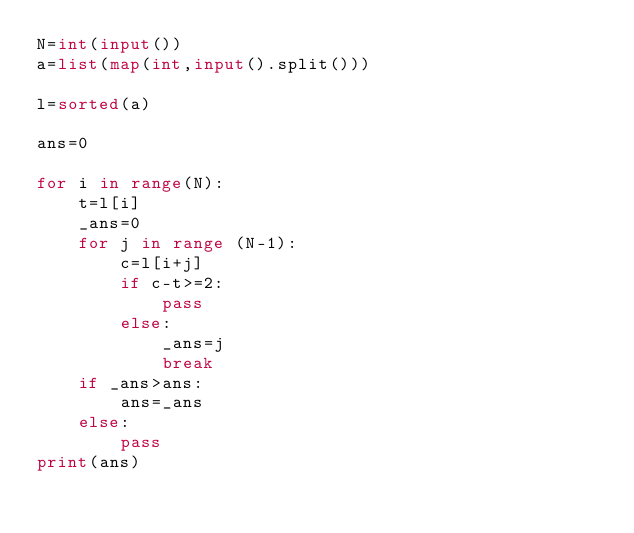Convert code to text. <code><loc_0><loc_0><loc_500><loc_500><_Python_>N=int(input())
a=list(map(int,input().split()))

l=sorted(a)

ans=0

for i in range(N):
    t=l[i]
    _ans=0
    for j in range (N-1):
        c=l[i+j]
        if c-t>=2:
            pass
        else:
            _ans=j
            break
    if _ans>ans:
        ans=_ans
    else:
        pass
print(ans)</code> 